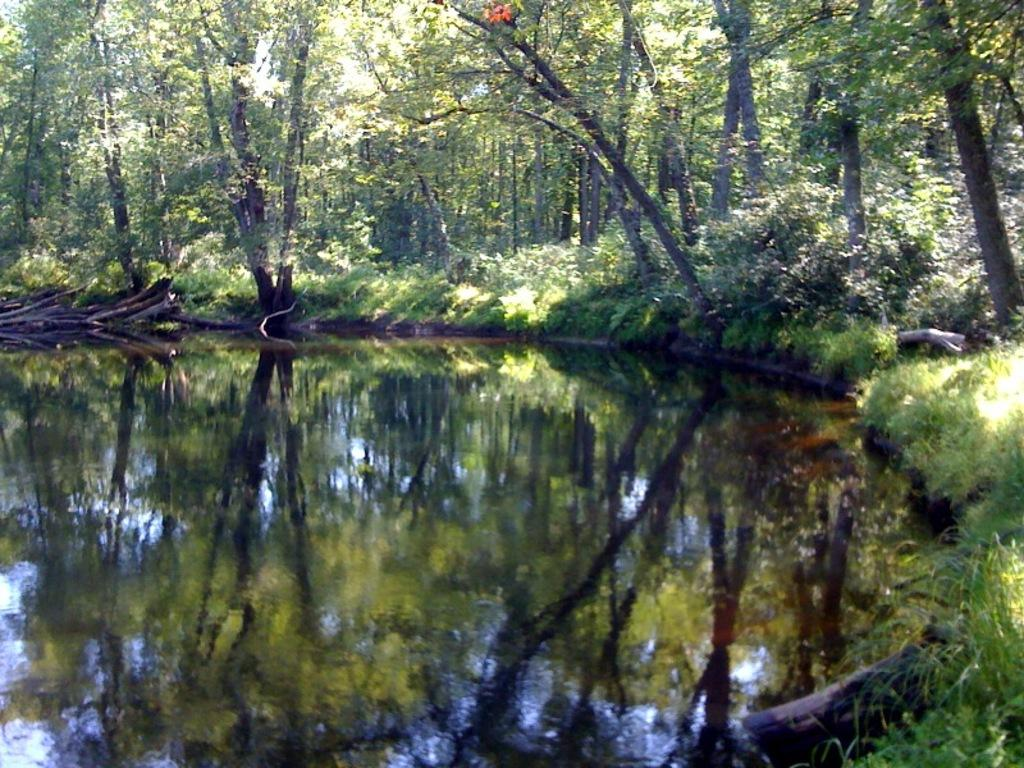What type of body of water is present at the bottom of the image? There is a pond at the bottom of the image. What type of vegetation can be seen in the background of the image? There are trees in the background of the image. What type of ground cover is visible in the image? There is grass visible in the image. What objects are located on the left side of the image? There are logs on the left side of the image. Can you see the cannon that your aunt gave you for your birthday in the image? There is no cannon or reference to an aunt in the image. What type of vest is being worn by the person in the image? There is no person or vest present in the image. 